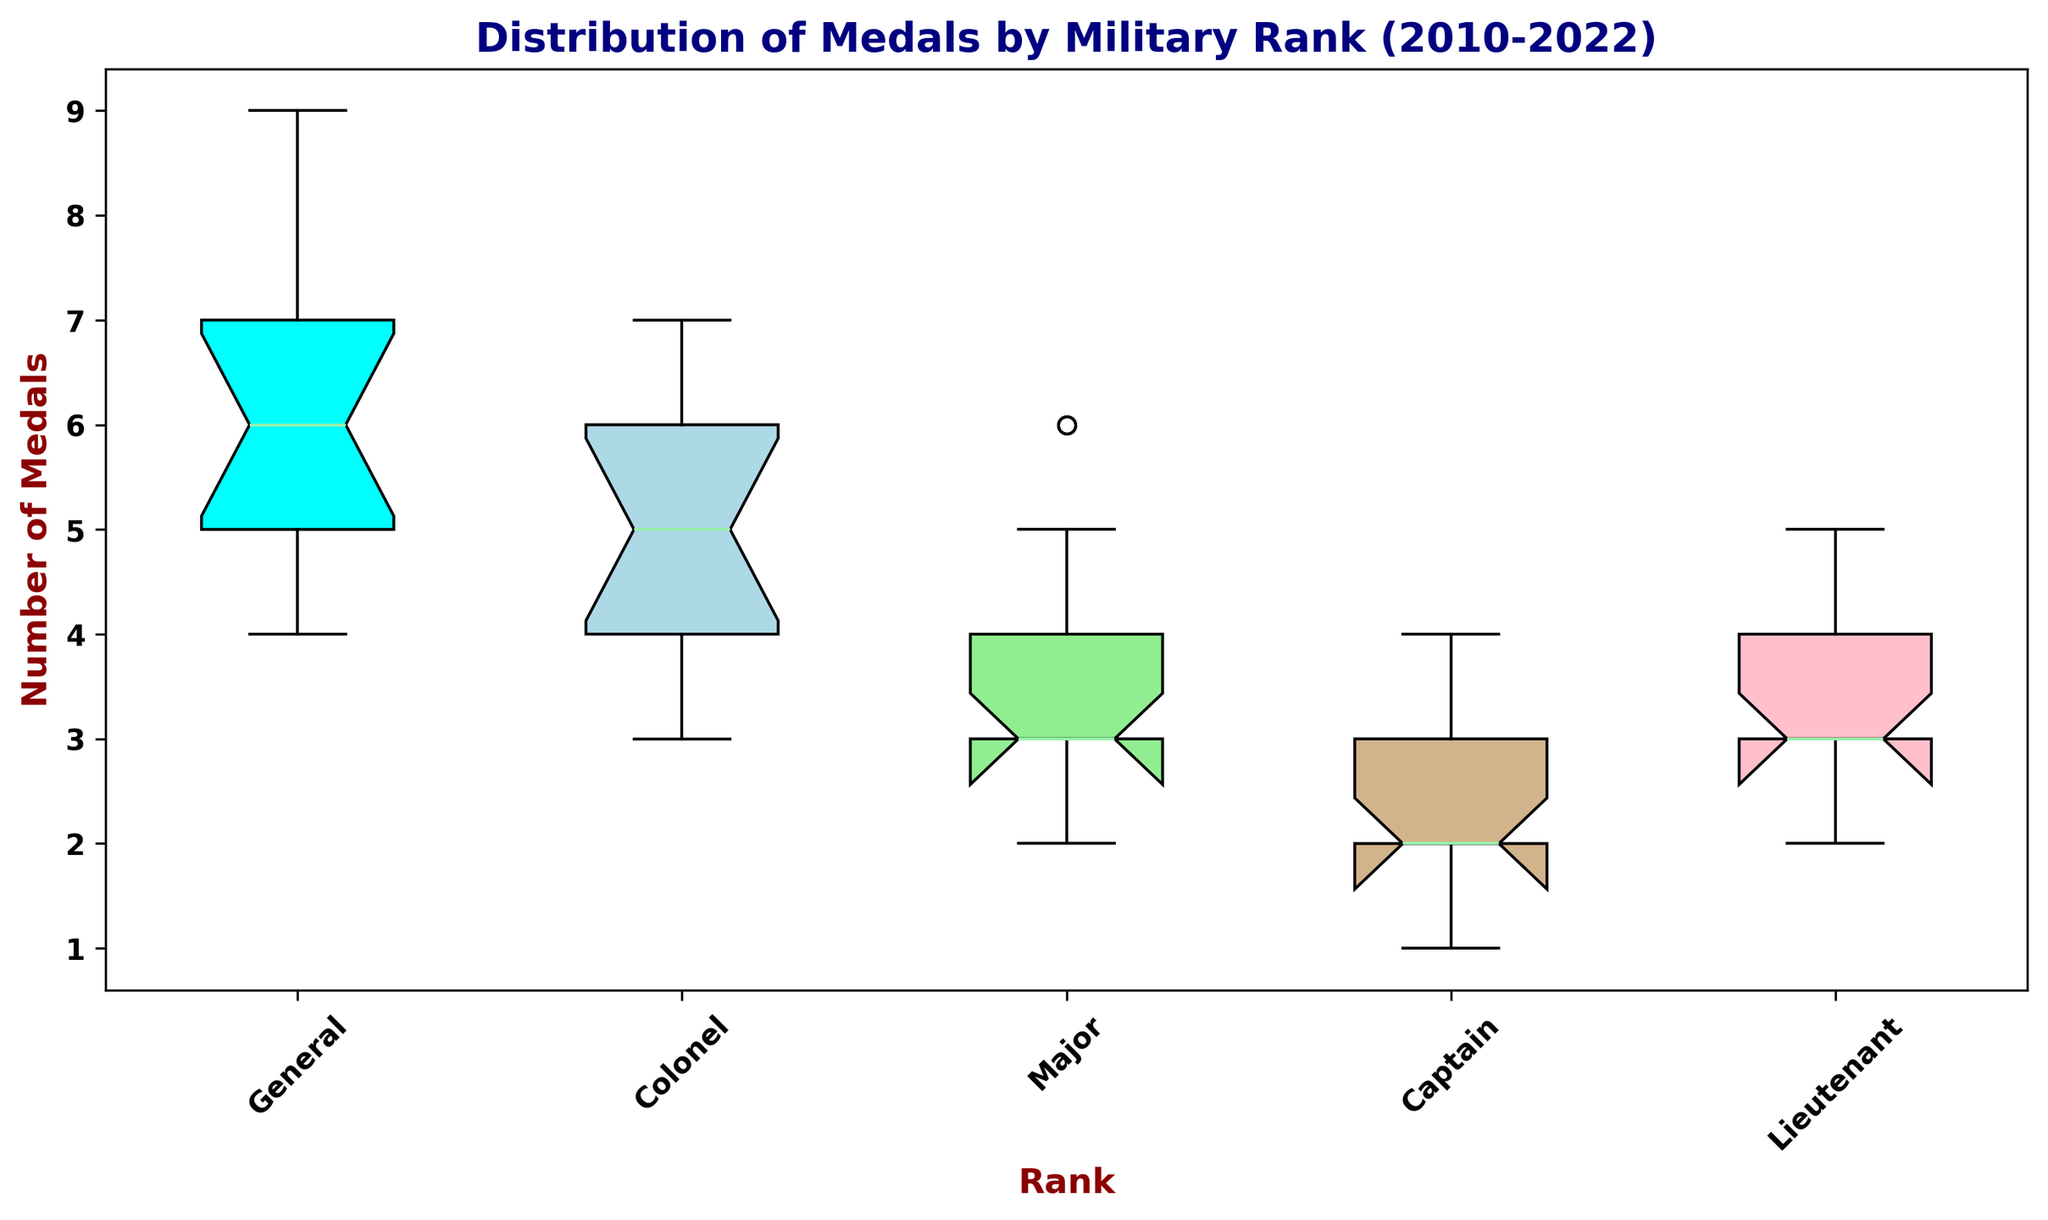What is the median number of medals for Generals? The median is indicated by the line inside the box in the box plot for Generals. Locate the box corresponding to Generals, find the line inside the box and check the Y-axis value of this line.
Answer: 6 Which rank has the highest median number of medals? Look at the line inside each box, indicating the median, and compare the ranks. The box with the highest median value corresponds to the rank with the highest median number of medals.
Answer: General Which rank shows the most variability in the number of medals? Variability is depicted by the length of the box plot's whiskers and the box itself. Look for the rank whose box plot has the widest spread.
Answer: Major How does the median number of medals for Colonels compare to that of Captains? Compare the medians by looking at the lines inside the boxes for both Colonels and Captains. The Y-axis values of these lines will indicate the medians for comparison.
Answer: Median for Colonels is higher than that for Captains What is the range of the number of medals awarded to Lieutenants? The range is calculated as the difference between the maximum and minimum values represented by the whiskers of the Lieutenants' box plot.
Answer: 1 Which rank appears to have the most consistent number of medals over the years? Consistency is shown by small variances in the box plot. Compare the lengths of the boxes and whiskers, and find the rank with the shortest overall length.
Answer: Lieutenant How does the number of medals awarded to Generals in 2022 compare to that in 2010? Refer to the year-by-year medals data in the provided data set: Generals received 5 medals in 2010 and 9 medals in 2022.
Answer: Generals received 4 more medals in 2022 What can be inferred about the trend of medals awarded to Majors over the years? By analyzing the data, we can observe how the number of medals for Majors changes over the years. Medals awarded to Majors generally increased from 2 medals in 2010 to 6 medals in 2022.
Answer: Increasing trend What does the interquartile range (IQR) of medals for Captains indicate? The IQR is the difference between the 75th percentile and the 25th percentile in the box plot for Captains. Find these values from the ends of the box for Captains and calculate the difference.
Answer: 1 Which rank has the least outliers in the number of medals awarded? Outliers are represented by dots outside the whiskers of the box plots. Look for the rank with the fewest or no dots beyond the box plot's whiskers.
Answer: Colonel 